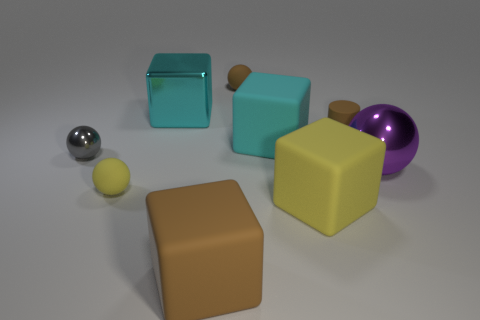How many other objects are the same size as the brown cube?
Keep it short and to the point. 4. There is a tiny ball that is in front of the big metal block and on the right side of the small gray object; what is its material?
Offer a very short reply. Rubber. There is a cyan block right of the cyan shiny object; is its size the same as the big yellow rubber cube?
Make the answer very short. Yes. What number of rubber balls are both behind the purple ball and in front of the brown sphere?
Offer a very short reply. 0. There is a tiny rubber thing in front of the big metallic object that is to the right of the large brown matte block; what number of cubes are behind it?
Ensure brevity in your answer.  2. There is another block that is the same color as the large metal cube; what is its size?
Ensure brevity in your answer.  Large. What is the shape of the big cyan metal thing?
Offer a very short reply. Cube. What number of tiny brown cylinders have the same material as the big sphere?
Offer a very short reply. 0. What color is the tiny object that is the same material as the large purple thing?
Ensure brevity in your answer.  Gray. There is a yellow rubber block; does it have the same size as the brown rubber object that is in front of the purple sphere?
Offer a very short reply. Yes. 